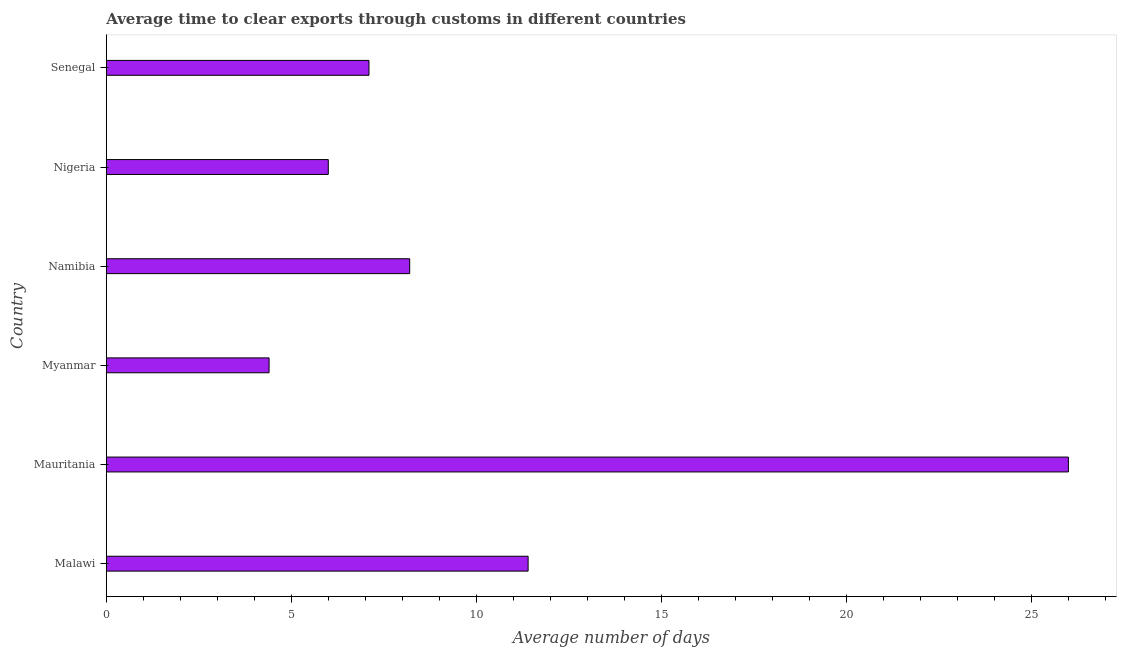Does the graph contain any zero values?
Your answer should be compact. No. Does the graph contain grids?
Make the answer very short. No. What is the title of the graph?
Offer a terse response. Average time to clear exports through customs in different countries. What is the label or title of the X-axis?
Provide a succinct answer. Average number of days. What is the label or title of the Y-axis?
Keep it short and to the point. Country. What is the time to clear exports through customs in Mauritania?
Your answer should be compact. 26. In which country was the time to clear exports through customs maximum?
Your response must be concise. Mauritania. In which country was the time to clear exports through customs minimum?
Provide a short and direct response. Myanmar. What is the sum of the time to clear exports through customs?
Ensure brevity in your answer.  63.1. What is the average time to clear exports through customs per country?
Offer a terse response. 10.52. What is the median time to clear exports through customs?
Give a very brief answer. 7.65. What is the ratio of the time to clear exports through customs in Namibia to that in Senegal?
Keep it short and to the point. 1.16. Is the time to clear exports through customs in Malawi less than that in Nigeria?
Make the answer very short. No. Is the difference between the time to clear exports through customs in Myanmar and Namibia greater than the difference between any two countries?
Ensure brevity in your answer.  No. What is the difference between the highest and the second highest time to clear exports through customs?
Make the answer very short. 14.6. What is the difference between the highest and the lowest time to clear exports through customs?
Give a very brief answer. 21.6. In how many countries, is the time to clear exports through customs greater than the average time to clear exports through customs taken over all countries?
Make the answer very short. 2. How many bars are there?
Provide a succinct answer. 6. Are all the bars in the graph horizontal?
Offer a terse response. Yes. What is the difference between two consecutive major ticks on the X-axis?
Make the answer very short. 5. Are the values on the major ticks of X-axis written in scientific E-notation?
Ensure brevity in your answer.  No. What is the Average number of days in Mauritania?
Provide a succinct answer. 26. What is the Average number of days in Senegal?
Ensure brevity in your answer.  7.1. What is the difference between the Average number of days in Malawi and Mauritania?
Your answer should be very brief. -14.6. What is the difference between the Average number of days in Mauritania and Myanmar?
Make the answer very short. 21.6. What is the difference between the Average number of days in Mauritania and Namibia?
Ensure brevity in your answer.  17.8. What is the difference between the Average number of days in Mauritania and Nigeria?
Your answer should be very brief. 20. What is the difference between the Average number of days in Myanmar and Nigeria?
Offer a very short reply. -1.6. What is the difference between the Average number of days in Namibia and Nigeria?
Give a very brief answer. 2.2. What is the difference between the Average number of days in Namibia and Senegal?
Your answer should be very brief. 1.1. What is the ratio of the Average number of days in Malawi to that in Mauritania?
Make the answer very short. 0.44. What is the ratio of the Average number of days in Malawi to that in Myanmar?
Your response must be concise. 2.59. What is the ratio of the Average number of days in Malawi to that in Namibia?
Offer a terse response. 1.39. What is the ratio of the Average number of days in Malawi to that in Nigeria?
Give a very brief answer. 1.9. What is the ratio of the Average number of days in Malawi to that in Senegal?
Provide a succinct answer. 1.61. What is the ratio of the Average number of days in Mauritania to that in Myanmar?
Your answer should be very brief. 5.91. What is the ratio of the Average number of days in Mauritania to that in Namibia?
Offer a terse response. 3.17. What is the ratio of the Average number of days in Mauritania to that in Nigeria?
Make the answer very short. 4.33. What is the ratio of the Average number of days in Mauritania to that in Senegal?
Your answer should be compact. 3.66. What is the ratio of the Average number of days in Myanmar to that in Namibia?
Give a very brief answer. 0.54. What is the ratio of the Average number of days in Myanmar to that in Nigeria?
Offer a terse response. 0.73. What is the ratio of the Average number of days in Myanmar to that in Senegal?
Make the answer very short. 0.62. What is the ratio of the Average number of days in Namibia to that in Nigeria?
Your response must be concise. 1.37. What is the ratio of the Average number of days in Namibia to that in Senegal?
Your answer should be very brief. 1.16. What is the ratio of the Average number of days in Nigeria to that in Senegal?
Ensure brevity in your answer.  0.84. 